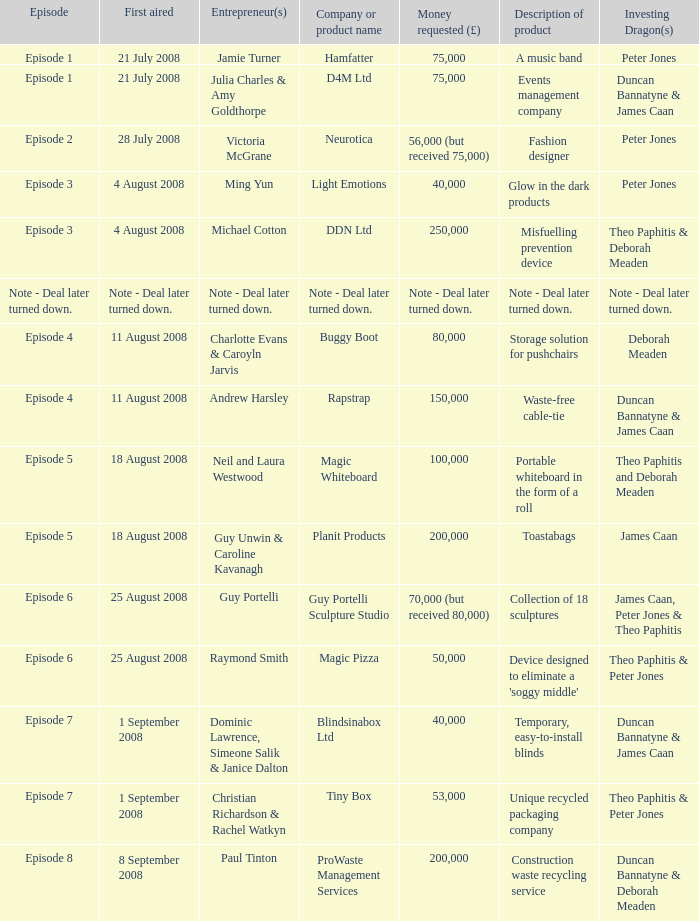What sum of money did the business neurotica solicit? 56,000 (but received 75,000). 